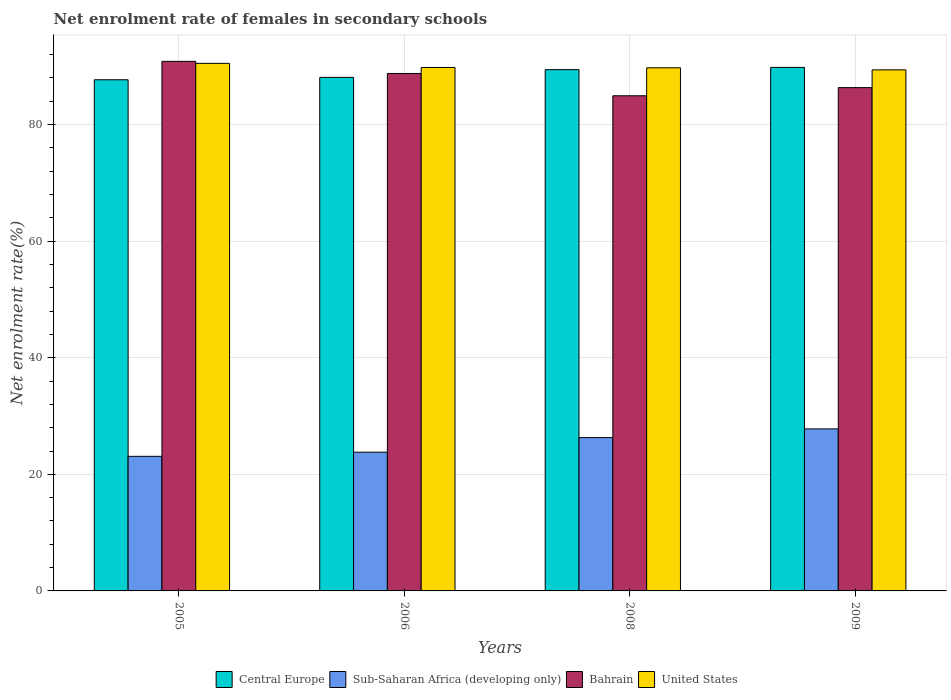How many different coloured bars are there?
Make the answer very short. 4. Are the number of bars per tick equal to the number of legend labels?
Give a very brief answer. Yes. Are the number of bars on each tick of the X-axis equal?
Give a very brief answer. Yes. How many bars are there on the 2nd tick from the left?
Offer a terse response. 4. How many bars are there on the 3rd tick from the right?
Provide a short and direct response. 4. What is the label of the 2nd group of bars from the left?
Ensure brevity in your answer.  2006. In how many cases, is the number of bars for a given year not equal to the number of legend labels?
Offer a terse response. 0. What is the net enrolment rate of females in secondary schools in Sub-Saharan Africa (developing only) in 2008?
Keep it short and to the point. 26.3. Across all years, what is the maximum net enrolment rate of females in secondary schools in Bahrain?
Offer a very short reply. 90.85. Across all years, what is the minimum net enrolment rate of females in secondary schools in Sub-Saharan Africa (developing only)?
Provide a short and direct response. 23.09. In which year was the net enrolment rate of females in secondary schools in Central Europe maximum?
Give a very brief answer. 2009. In which year was the net enrolment rate of females in secondary schools in Central Europe minimum?
Provide a succinct answer. 2005. What is the total net enrolment rate of females in secondary schools in United States in the graph?
Keep it short and to the point. 359.44. What is the difference between the net enrolment rate of females in secondary schools in Bahrain in 2005 and that in 2008?
Offer a very short reply. 5.91. What is the difference between the net enrolment rate of females in secondary schools in Central Europe in 2008 and the net enrolment rate of females in secondary schools in Sub-Saharan Africa (developing only) in 2006?
Keep it short and to the point. 65.63. What is the average net enrolment rate of females in secondary schools in Central Europe per year?
Ensure brevity in your answer.  88.76. In the year 2009, what is the difference between the net enrolment rate of females in secondary schools in Central Europe and net enrolment rate of females in secondary schools in Bahrain?
Offer a very short reply. 3.47. In how many years, is the net enrolment rate of females in secondary schools in Central Europe greater than 76 %?
Provide a succinct answer. 4. What is the ratio of the net enrolment rate of females in secondary schools in Sub-Saharan Africa (developing only) in 2005 to that in 2009?
Ensure brevity in your answer.  0.83. Is the difference between the net enrolment rate of females in secondary schools in Central Europe in 2006 and 2008 greater than the difference between the net enrolment rate of females in secondary schools in Bahrain in 2006 and 2008?
Offer a very short reply. No. What is the difference between the highest and the second highest net enrolment rate of females in secondary schools in Sub-Saharan Africa (developing only)?
Keep it short and to the point. 1.49. What is the difference between the highest and the lowest net enrolment rate of females in secondary schools in United States?
Provide a succinct answer. 1.12. Is the sum of the net enrolment rate of females in secondary schools in Bahrain in 2006 and 2008 greater than the maximum net enrolment rate of females in secondary schools in United States across all years?
Your answer should be compact. Yes. What does the 4th bar from the left in 2005 represents?
Give a very brief answer. United States. Is it the case that in every year, the sum of the net enrolment rate of females in secondary schools in Sub-Saharan Africa (developing only) and net enrolment rate of females in secondary schools in Central Europe is greater than the net enrolment rate of females in secondary schools in Bahrain?
Keep it short and to the point. Yes. How many bars are there?
Offer a terse response. 16. Are all the bars in the graph horizontal?
Your answer should be compact. No. How many years are there in the graph?
Your answer should be very brief. 4. What is the difference between two consecutive major ticks on the Y-axis?
Your response must be concise. 20. How many legend labels are there?
Ensure brevity in your answer.  4. How are the legend labels stacked?
Provide a short and direct response. Horizontal. What is the title of the graph?
Give a very brief answer. Net enrolment rate of females in secondary schools. What is the label or title of the Y-axis?
Your answer should be very brief. Net enrolment rate(%). What is the Net enrolment rate(%) in Central Europe in 2005?
Ensure brevity in your answer.  87.69. What is the Net enrolment rate(%) of Sub-Saharan Africa (developing only) in 2005?
Make the answer very short. 23.09. What is the Net enrolment rate(%) in Bahrain in 2005?
Make the answer very short. 90.85. What is the Net enrolment rate(%) in United States in 2005?
Make the answer very short. 90.51. What is the Net enrolment rate(%) of Central Europe in 2006?
Provide a short and direct response. 88.1. What is the Net enrolment rate(%) of Sub-Saharan Africa (developing only) in 2006?
Make the answer very short. 23.8. What is the Net enrolment rate(%) in Bahrain in 2006?
Ensure brevity in your answer.  88.77. What is the Net enrolment rate(%) of United States in 2006?
Your answer should be compact. 89.8. What is the Net enrolment rate(%) of Central Europe in 2008?
Your answer should be very brief. 89.43. What is the Net enrolment rate(%) of Sub-Saharan Africa (developing only) in 2008?
Offer a very short reply. 26.3. What is the Net enrolment rate(%) in Bahrain in 2008?
Make the answer very short. 84.95. What is the Net enrolment rate(%) in United States in 2008?
Your answer should be very brief. 89.75. What is the Net enrolment rate(%) in Central Europe in 2009?
Offer a terse response. 89.82. What is the Net enrolment rate(%) in Sub-Saharan Africa (developing only) in 2009?
Your answer should be compact. 27.8. What is the Net enrolment rate(%) in Bahrain in 2009?
Provide a succinct answer. 86.35. What is the Net enrolment rate(%) of United States in 2009?
Your answer should be compact. 89.39. Across all years, what is the maximum Net enrolment rate(%) in Central Europe?
Your answer should be very brief. 89.82. Across all years, what is the maximum Net enrolment rate(%) in Sub-Saharan Africa (developing only)?
Offer a very short reply. 27.8. Across all years, what is the maximum Net enrolment rate(%) of Bahrain?
Your answer should be very brief. 90.85. Across all years, what is the maximum Net enrolment rate(%) of United States?
Your answer should be compact. 90.51. Across all years, what is the minimum Net enrolment rate(%) in Central Europe?
Your response must be concise. 87.69. Across all years, what is the minimum Net enrolment rate(%) of Sub-Saharan Africa (developing only)?
Your answer should be very brief. 23.09. Across all years, what is the minimum Net enrolment rate(%) of Bahrain?
Give a very brief answer. 84.95. Across all years, what is the minimum Net enrolment rate(%) of United States?
Ensure brevity in your answer.  89.39. What is the total Net enrolment rate(%) of Central Europe in the graph?
Ensure brevity in your answer.  355.04. What is the total Net enrolment rate(%) in Sub-Saharan Africa (developing only) in the graph?
Make the answer very short. 100.99. What is the total Net enrolment rate(%) in Bahrain in the graph?
Offer a very short reply. 350.91. What is the total Net enrolment rate(%) of United States in the graph?
Your answer should be compact. 359.44. What is the difference between the Net enrolment rate(%) of Central Europe in 2005 and that in 2006?
Keep it short and to the point. -0.41. What is the difference between the Net enrolment rate(%) in Sub-Saharan Africa (developing only) in 2005 and that in 2006?
Give a very brief answer. -0.71. What is the difference between the Net enrolment rate(%) in Bahrain in 2005 and that in 2006?
Your answer should be very brief. 2.08. What is the difference between the Net enrolment rate(%) of United States in 2005 and that in 2006?
Keep it short and to the point. 0.71. What is the difference between the Net enrolment rate(%) of Central Europe in 2005 and that in 2008?
Make the answer very short. -1.74. What is the difference between the Net enrolment rate(%) in Sub-Saharan Africa (developing only) in 2005 and that in 2008?
Offer a very short reply. -3.21. What is the difference between the Net enrolment rate(%) in Bahrain in 2005 and that in 2008?
Your response must be concise. 5.91. What is the difference between the Net enrolment rate(%) of United States in 2005 and that in 2008?
Your answer should be very brief. 0.76. What is the difference between the Net enrolment rate(%) in Central Europe in 2005 and that in 2009?
Give a very brief answer. -2.12. What is the difference between the Net enrolment rate(%) in Sub-Saharan Africa (developing only) in 2005 and that in 2009?
Ensure brevity in your answer.  -4.71. What is the difference between the Net enrolment rate(%) in Bahrain in 2005 and that in 2009?
Provide a short and direct response. 4.5. What is the difference between the Net enrolment rate(%) of United States in 2005 and that in 2009?
Offer a very short reply. 1.12. What is the difference between the Net enrolment rate(%) in Central Europe in 2006 and that in 2008?
Offer a terse response. -1.33. What is the difference between the Net enrolment rate(%) in Sub-Saharan Africa (developing only) in 2006 and that in 2008?
Make the answer very short. -2.5. What is the difference between the Net enrolment rate(%) in Bahrain in 2006 and that in 2008?
Your answer should be very brief. 3.83. What is the difference between the Net enrolment rate(%) of United States in 2006 and that in 2008?
Provide a succinct answer. 0.05. What is the difference between the Net enrolment rate(%) of Central Europe in 2006 and that in 2009?
Ensure brevity in your answer.  -1.72. What is the difference between the Net enrolment rate(%) in Sub-Saharan Africa (developing only) in 2006 and that in 2009?
Give a very brief answer. -4. What is the difference between the Net enrolment rate(%) of Bahrain in 2006 and that in 2009?
Your answer should be very brief. 2.42. What is the difference between the Net enrolment rate(%) in United States in 2006 and that in 2009?
Offer a very short reply. 0.41. What is the difference between the Net enrolment rate(%) in Central Europe in 2008 and that in 2009?
Your answer should be very brief. -0.39. What is the difference between the Net enrolment rate(%) in Sub-Saharan Africa (developing only) in 2008 and that in 2009?
Keep it short and to the point. -1.49. What is the difference between the Net enrolment rate(%) in Bahrain in 2008 and that in 2009?
Keep it short and to the point. -1.4. What is the difference between the Net enrolment rate(%) of United States in 2008 and that in 2009?
Give a very brief answer. 0.36. What is the difference between the Net enrolment rate(%) of Central Europe in 2005 and the Net enrolment rate(%) of Sub-Saharan Africa (developing only) in 2006?
Provide a succinct answer. 63.89. What is the difference between the Net enrolment rate(%) of Central Europe in 2005 and the Net enrolment rate(%) of Bahrain in 2006?
Your response must be concise. -1.08. What is the difference between the Net enrolment rate(%) of Central Europe in 2005 and the Net enrolment rate(%) of United States in 2006?
Your response must be concise. -2.1. What is the difference between the Net enrolment rate(%) in Sub-Saharan Africa (developing only) in 2005 and the Net enrolment rate(%) in Bahrain in 2006?
Keep it short and to the point. -65.68. What is the difference between the Net enrolment rate(%) in Sub-Saharan Africa (developing only) in 2005 and the Net enrolment rate(%) in United States in 2006?
Offer a very short reply. -66.71. What is the difference between the Net enrolment rate(%) of Bahrain in 2005 and the Net enrolment rate(%) of United States in 2006?
Ensure brevity in your answer.  1.05. What is the difference between the Net enrolment rate(%) of Central Europe in 2005 and the Net enrolment rate(%) of Sub-Saharan Africa (developing only) in 2008?
Provide a succinct answer. 61.39. What is the difference between the Net enrolment rate(%) of Central Europe in 2005 and the Net enrolment rate(%) of Bahrain in 2008?
Give a very brief answer. 2.75. What is the difference between the Net enrolment rate(%) of Central Europe in 2005 and the Net enrolment rate(%) of United States in 2008?
Give a very brief answer. -2.05. What is the difference between the Net enrolment rate(%) of Sub-Saharan Africa (developing only) in 2005 and the Net enrolment rate(%) of Bahrain in 2008?
Offer a very short reply. -61.86. What is the difference between the Net enrolment rate(%) of Sub-Saharan Africa (developing only) in 2005 and the Net enrolment rate(%) of United States in 2008?
Your response must be concise. -66.66. What is the difference between the Net enrolment rate(%) of Bahrain in 2005 and the Net enrolment rate(%) of United States in 2008?
Your answer should be very brief. 1.1. What is the difference between the Net enrolment rate(%) of Central Europe in 2005 and the Net enrolment rate(%) of Sub-Saharan Africa (developing only) in 2009?
Provide a succinct answer. 59.9. What is the difference between the Net enrolment rate(%) in Central Europe in 2005 and the Net enrolment rate(%) in Bahrain in 2009?
Give a very brief answer. 1.35. What is the difference between the Net enrolment rate(%) of Central Europe in 2005 and the Net enrolment rate(%) of United States in 2009?
Your response must be concise. -1.7. What is the difference between the Net enrolment rate(%) in Sub-Saharan Africa (developing only) in 2005 and the Net enrolment rate(%) in Bahrain in 2009?
Keep it short and to the point. -63.26. What is the difference between the Net enrolment rate(%) of Sub-Saharan Africa (developing only) in 2005 and the Net enrolment rate(%) of United States in 2009?
Your answer should be compact. -66.3. What is the difference between the Net enrolment rate(%) in Bahrain in 2005 and the Net enrolment rate(%) in United States in 2009?
Offer a very short reply. 1.46. What is the difference between the Net enrolment rate(%) of Central Europe in 2006 and the Net enrolment rate(%) of Sub-Saharan Africa (developing only) in 2008?
Your answer should be compact. 61.8. What is the difference between the Net enrolment rate(%) of Central Europe in 2006 and the Net enrolment rate(%) of Bahrain in 2008?
Your answer should be compact. 3.15. What is the difference between the Net enrolment rate(%) in Central Europe in 2006 and the Net enrolment rate(%) in United States in 2008?
Make the answer very short. -1.65. What is the difference between the Net enrolment rate(%) of Sub-Saharan Africa (developing only) in 2006 and the Net enrolment rate(%) of Bahrain in 2008?
Provide a short and direct response. -61.15. What is the difference between the Net enrolment rate(%) in Sub-Saharan Africa (developing only) in 2006 and the Net enrolment rate(%) in United States in 2008?
Your answer should be compact. -65.95. What is the difference between the Net enrolment rate(%) of Bahrain in 2006 and the Net enrolment rate(%) of United States in 2008?
Your response must be concise. -0.98. What is the difference between the Net enrolment rate(%) of Central Europe in 2006 and the Net enrolment rate(%) of Sub-Saharan Africa (developing only) in 2009?
Provide a short and direct response. 60.3. What is the difference between the Net enrolment rate(%) of Central Europe in 2006 and the Net enrolment rate(%) of Bahrain in 2009?
Offer a very short reply. 1.75. What is the difference between the Net enrolment rate(%) in Central Europe in 2006 and the Net enrolment rate(%) in United States in 2009?
Offer a terse response. -1.29. What is the difference between the Net enrolment rate(%) of Sub-Saharan Africa (developing only) in 2006 and the Net enrolment rate(%) of Bahrain in 2009?
Ensure brevity in your answer.  -62.55. What is the difference between the Net enrolment rate(%) in Sub-Saharan Africa (developing only) in 2006 and the Net enrolment rate(%) in United States in 2009?
Keep it short and to the point. -65.59. What is the difference between the Net enrolment rate(%) in Bahrain in 2006 and the Net enrolment rate(%) in United States in 2009?
Your answer should be compact. -0.62. What is the difference between the Net enrolment rate(%) in Central Europe in 2008 and the Net enrolment rate(%) in Sub-Saharan Africa (developing only) in 2009?
Your answer should be compact. 61.63. What is the difference between the Net enrolment rate(%) in Central Europe in 2008 and the Net enrolment rate(%) in Bahrain in 2009?
Provide a short and direct response. 3.08. What is the difference between the Net enrolment rate(%) in Central Europe in 2008 and the Net enrolment rate(%) in United States in 2009?
Give a very brief answer. 0.04. What is the difference between the Net enrolment rate(%) of Sub-Saharan Africa (developing only) in 2008 and the Net enrolment rate(%) of Bahrain in 2009?
Provide a short and direct response. -60.04. What is the difference between the Net enrolment rate(%) in Sub-Saharan Africa (developing only) in 2008 and the Net enrolment rate(%) in United States in 2009?
Provide a short and direct response. -63.09. What is the difference between the Net enrolment rate(%) in Bahrain in 2008 and the Net enrolment rate(%) in United States in 2009?
Your answer should be compact. -4.45. What is the average Net enrolment rate(%) in Central Europe per year?
Provide a succinct answer. 88.76. What is the average Net enrolment rate(%) of Sub-Saharan Africa (developing only) per year?
Make the answer very short. 25.25. What is the average Net enrolment rate(%) of Bahrain per year?
Ensure brevity in your answer.  87.73. What is the average Net enrolment rate(%) of United States per year?
Give a very brief answer. 89.86. In the year 2005, what is the difference between the Net enrolment rate(%) of Central Europe and Net enrolment rate(%) of Sub-Saharan Africa (developing only)?
Ensure brevity in your answer.  64.6. In the year 2005, what is the difference between the Net enrolment rate(%) of Central Europe and Net enrolment rate(%) of Bahrain?
Make the answer very short. -3.16. In the year 2005, what is the difference between the Net enrolment rate(%) of Central Europe and Net enrolment rate(%) of United States?
Give a very brief answer. -2.81. In the year 2005, what is the difference between the Net enrolment rate(%) of Sub-Saharan Africa (developing only) and Net enrolment rate(%) of Bahrain?
Provide a succinct answer. -67.76. In the year 2005, what is the difference between the Net enrolment rate(%) of Sub-Saharan Africa (developing only) and Net enrolment rate(%) of United States?
Keep it short and to the point. -67.42. In the year 2005, what is the difference between the Net enrolment rate(%) of Bahrain and Net enrolment rate(%) of United States?
Provide a short and direct response. 0.34. In the year 2006, what is the difference between the Net enrolment rate(%) in Central Europe and Net enrolment rate(%) in Sub-Saharan Africa (developing only)?
Your answer should be compact. 64.3. In the year 2006, what is the difference between the Net enrolment rate(%) in Central Europe and Net enrolment rate(%) in Bahrain?
Keep it short and to the point. -0.67. In the year 2006, what is the difference between the Net enrolment rate(%) in Central Europe and Net enrolment rate(%) in United States?
Your answer should be very brief. -1.7. In the year 2006, what is the difference between the Net enrolment rate(%) in Sub-Saharan Africa (developing only) and Net enrolment rate(%) in Bahrain?
Keep it short and to the point. -64.97. In the year 2006, what is the difference between the Net enrolment rate(%) of Sub-Saharan Africa (developing only) and Net enrolment rate(%) of United States?
Provide a short and direct response. -66. In the year 2006, what is the difference between the Net enrolment rate(%) in Bahrain and Net enrolment rate(%) in United States?
Keep it short and to the point. -1.03. In the year 2008, what is the difference between the Net enrolment rate(%) of Central Europe and Net enrolment rate(%) of Sub-Saharan Africa (developing only)?
Offer a terse response. 63.13. In the year 2008, what is the difference between the Net enrolment rate(%) in Central Europe and Net enrolment rate(%) in Bahrain?
Your response must be concise. 4.48. In the year 2008, what is the difference between the Net enrolment rate(%) in Central Europe and Net enrolment rate(%) in United States?
Provide a succinct answer. -0.32. In the year 2008, what is the difference between the Net enrolment rate(%) in Sub-Saharan Africa (developing only) and Net enrolment rate(%) in Bahrain?
Offer a terse response. -58.64. In the year 2008, what is the difference between the Net enrolment rate(%) in Sub-Saharan Africa (developing only) and Net enrolment rate(%) in United States?
Offer a terse response. -63.44. In the year 2008, what is the difference between the Net enrolment rate(%) of Bahrain and Net enrolment rate(%) of United States?
Give a very brief answer. -4.8. In the year 2009, what is the difference between the Net enrolment rate(%) of Central Europe and Net enrolment rate(%) of Sub-Saharan Africa (developing only)?
Provide a short and direct response. 62.02. In the year 2009, what is the difference between the Net enrolment rate(%) in Central Europe and Net enrolment rate(%) in Bahrain?
Make the answer very short. 3.47. In the year 2009, what is the difference between the Net enrolment rate(%) of Central Europe and Net enrolment rate(%) of United States?
Make the answer very short. 0.43. In the year 2009, what is the difference between the Net enrolment rate(%) in Sub-Saharan Africa (developing only) and Net enrolment rate(%) in Bahrain?
Make the answer very short. -58.55. In the year 2009, what is the difference between the Net enrolment rate(%) of Sub-Saharan Africa (developing only) and Net enrolment rate(%) of United States?
Give a very brief answer. -61.59. In the year 2009, what is the difference between the Net enrolment rate(%) in Bahrain and Net enrolment rate(%) in United States?
Provide a short and direct response. -3.05. What is the ratio of the Net enrolment rate(%) of Sub-Saharan Africa (developing only) in 2005 to that in 2006?
Offer a terse response. 0.97. What is the ratio of the Net enrolment rate(%) of Bahrain in 2005 to that in 2006?
Keep it short and to the point. 1.02. What is the ratio of the Net enrolment rate(%) of United States in 2005 to that in 2006?
Give a very brief answer. 1.01. What is the ratio of the Net enrolment rate(%) in Central Europe in 2005 to that in 2008?
Your answer should be compact. 0.98. What is the ratio of the Net enrolment rate(%) of Sub-Saharan Africa (developing only) in 2005 to that in 2008?
Ensure brevity in your answer.  0.88. What is the ratio of the Net enrolment rate(%) of Bahrain in 2005 to that in 2008?
Ensure brevity in your answer.  1.07. What is the ratio of the Net enrolment rate(%) in United States in 2005 to that in 2008?
Keep it short and to the point. 1.01. What is the ratio of the Net enrolment rate(%) in Central Europe in 2005 to that in 2009?
Provide a short and direct response. 0.98. What is the ratio of the Net enrolment rate(%) in Sub-Saharan Africa (developing only) in 2005 to that in 2009?
Your answer should be compact. 0.83. What is the ratio of the Net enrolment rate(%) of Bahrain in 2005 to that in 2009?
Your answer should be very brief. 1.05. What is the ratio of the Net enrolment rate(%) of United States in 2005 to that in 2009?
Give a very brief answer. 1.01. What is the ratio of the Net enrolment rate(%) in Central Europe in 2006 to that in 2008?
Your answer should be very brief. 0.99. What is the ratio of the Net enrolment rate(%) of Sub-Saharan Africa (developing only) in 2006 to that in 2008?
Give a very brief answer. 0.9. What is the ratio of the Net enrolment rate(%) in Bahrain in 2006 to that in 2008?
Your answer should be compact. 1.04. What is the ratio of the Net enrolment rate(%) of Central Europe in 2006 to that in 2009?
Provide a succinct answer. 0.98. What is the ratio of the Net enrolment rate(%) of Sub-Saharan Africa (developing only) in 2006 to that in 2009?
Make the answer very short. 0.86. What is the ratio of the Net enrolment rate(%) of Bahrain in 2006 to that in 2009?
Offer a terse response. 1.03. What is the ratio of the Net enrolment rate(%) of Central Europe in 2008 to that in 2009?
Keep it short and to the point. 1. What is the ratio of the Net enrolment rate(%) in Sub-Saharan Africa (developing only) in 2008 to that in 2009?
Keep it short and to the point. 0.95. What is the ratio of the Net enrolment rate(%) of Bahrain in 2008 to that in 2009?
Offer a terse response. 0.98. What is the difference between the highest and the second highest Net enrolment rate(%) in Central Europe?
Make the answer very short. 0.39. What is the difference between the highest and the second highest Net enrolment rate(%) in Sub-Saharan Africa (developing only)?
Provide a succinct answer. 1.49. What is the difference between the highest and the second highest Net enrolment rate(%) of Bahrain?
Give a very brief answer. 2.08. What is the difference between the highest and the second highest Net enrolment rate(%) in United States?
Offer a very short reply. 0.71. What is the difference between the highest and the lowest Net enrolment rate(%) in Central Europe?
Your answer should be compact. 2.12. What is the difference between the highest and the lowest Net enrolment rate(%) of Sub-Saharan Africa (developing only)?
Provide a short and direct response. 4.71. What is the difference between the highest and the lowest Net enrolment rate(%) of Bahrain?
Your answer should be compact. 5.91. What is the difference between the highest and the lowest Net enrolment rate(%) of United States?
Provide a succinct answer. 1.12. 